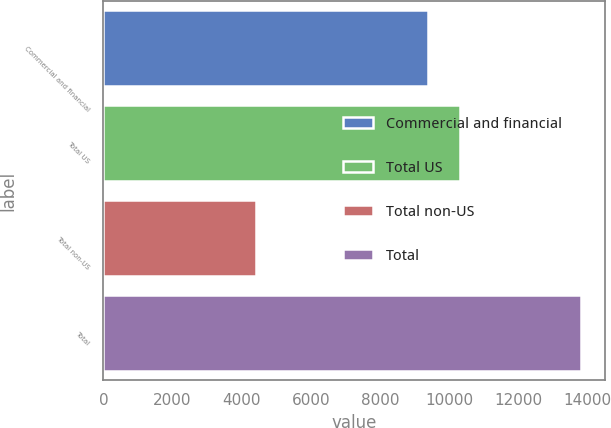<chart> <loc_0><loc_0><loc_500><loc_500><bar_chart><fcel>Commercial and financial<fcel>Total US<fcel>Total non-US<fcel>Total<nl><fcel>9372<fcel>10310<fcel>4419<fcel>13799<nl></chart> 